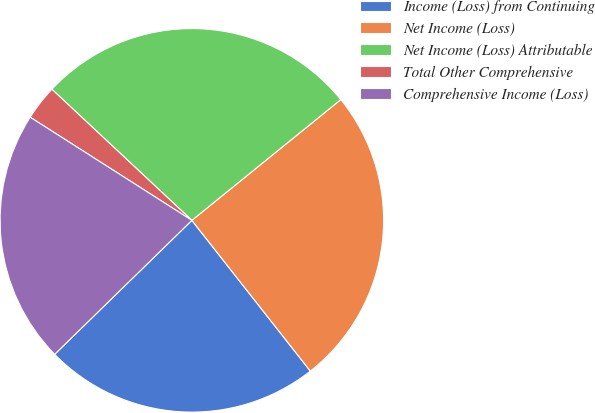Convert chart to OTSL. <chart><loc_0><loc_0><loc_500><loc_500><pie_chart><fcel>Income (Loss) from Continuing<fcel>Net Income (Loss)<fcel>Net Income (Loss) Attributable<fcel>Total Other Comprehensive<fcel>Comprehensive Income (Loss)<nl><fcel>23.29%<fcel>25.24%<fcel>27.18%<fcel>2.94%<fcel>21.35%<nl></chart> 